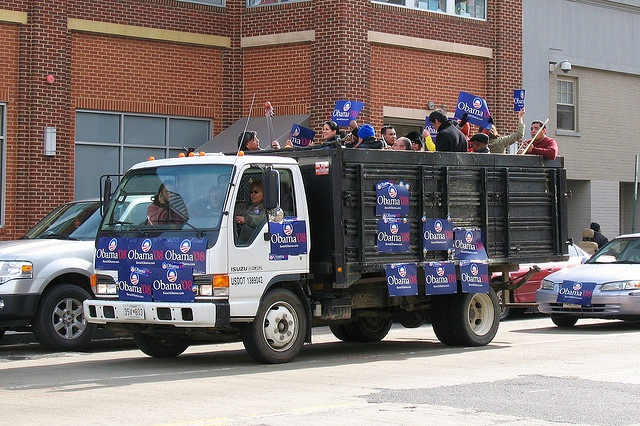Describe the objects in this image and their specific colors. I can see truck in maroon, black, gray, lightgray, and navy tones, truck in maroon, black, white, gray, and darkgray tones, car in maroon, white, gray, black, and darkgray tones, car in maroon, white, black, and gray tones, and people in maroon, gray, and darkgray tones in this image. 